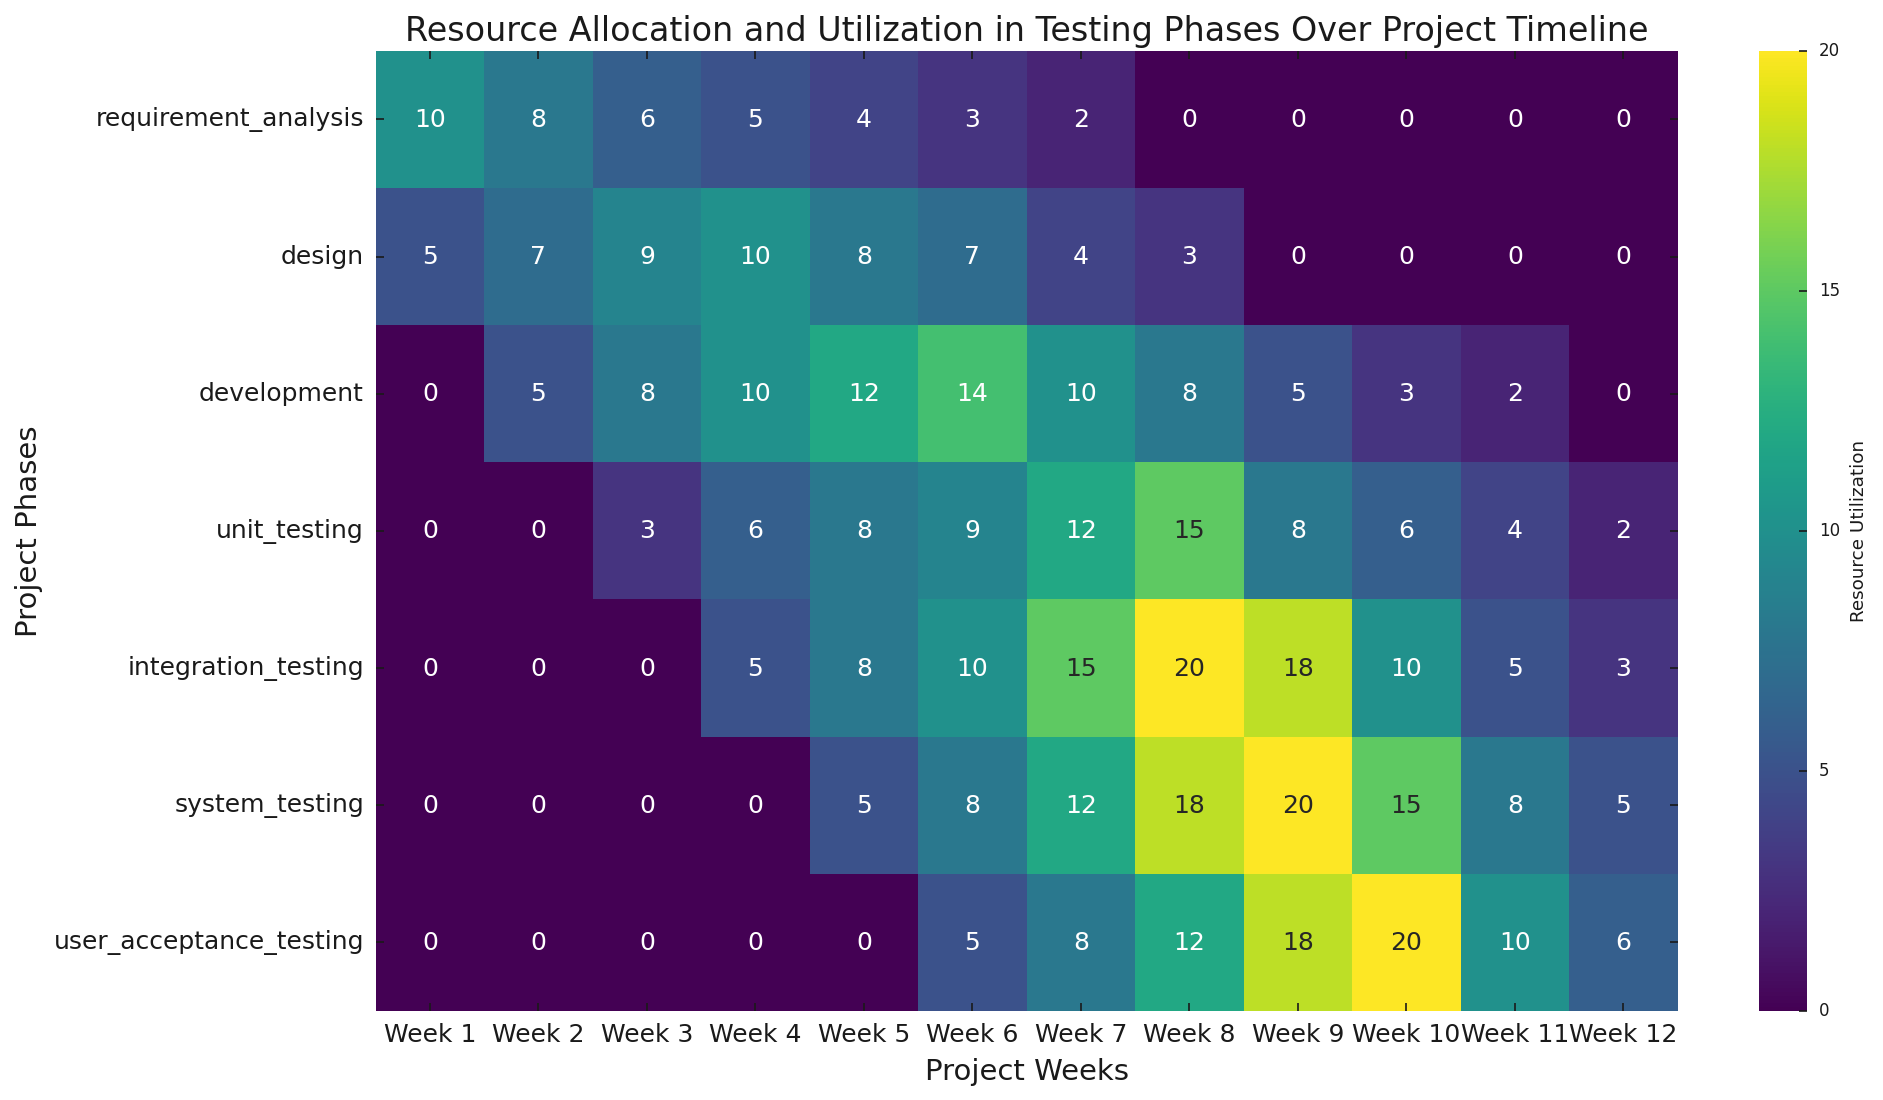What is the maximum resource utilization for the "integration_testing" phase? Look at the row for "integration_testing" and identify the highest number in that row, which represents the peak resource utilization during that phase.
Answer: 20 How does the resource allocation in "development" change from week 1 to week 12? Observe the "development" row and note the values from week 1 to week 12. The values increase from 0 in week 1 to 14 in week 6 and then gradually decrease to 0 by week 12.
Answer: Peaks at week 6 and then declines Which phase utilizes the most resources during week 9? Look at the column for week 9 and identify the highest number. The row corresponding to this number represents the phase with the most resource utilization in week 9.
Answer: system_testing What is the average resource utilization during weeks 1 to 4 for "design"? Calculate the average by adding the values for weeks 1 to 4 in the "design" row (5 + 7 + 9 + 10) and then dividing by 4.
Answer: 7.75 Compare the resource allocation between "system_testing" and "user_acceptance_testing" in weeks 8 and 10. For week 8, "system_testing" has 18 and "user_acceptance_testing" has 12. For week 10, "system_testing" has 15 and "user_acceptance_testing" has 20.
Answer: Week 8: system_testing higher, Week 10: user_acceptance_testing higher What is the total resource utilization for "unit_testing" over the entire 12 weeks? Sum all the numbers in the "unit_testing" row (0 + 0 + 3 + 6 + 8 + 9 + 12 + 15 + 8 + 6 + 4 + 2).
Answer: 73 Which phase has the steepest increase in resource allocation over any consecutive two-week period? Look for the phase with the largest increase by comparing the differences between consecutive weeks. "integration_testing" from week 7 (15) to week 8 (20) and "unit_testing" from week 6 (9) to week 7 (12) show significant increases. The steepest is from week 6 to week 7 for unit_testing.
Answer: integration_testing (week 7 to week 8) During which week does "requirement_analysis" phase have zero resource utilization, indicating its completion? Scan the "requirement_analysis" row and see the first week with a 0 value.
Answer: Week 8 How does the resource utilization pattern for "user_acceptance_testing" differ from that of "integration_testing"? Examine the "user_acceptance_testing" and "integration_testing" rows. "integration_testing" starts earlier in week 4, peaks at week 8 and declines, while "user_acceptance_testing" starts at week 6, peaks at week 10, and then declines.
Answer: Starts later, peaks later What is the cumulative resource utilization for all phases in week 6? Sum all values in the column for week 6 (3 + 7 + 14 + 9 + 10 + 8 + 5).
Answer: 56 